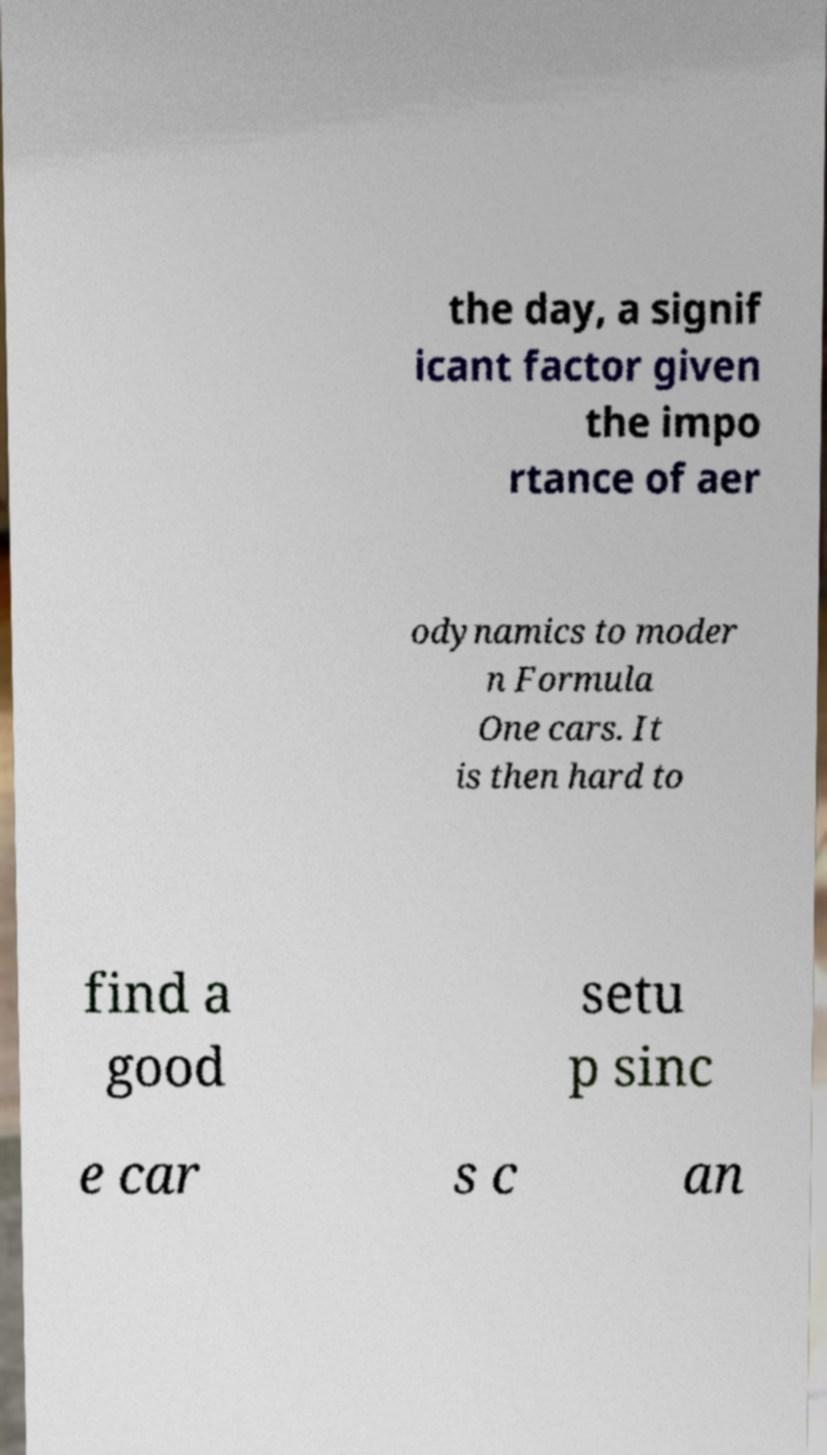Can you accurately transcribe the text from the provided image for me? the day, a signif icant factor given the impo rtance of aer odynamics to moder n Formula One cars. It is then hard to find a good setu p sinc e car s c an 